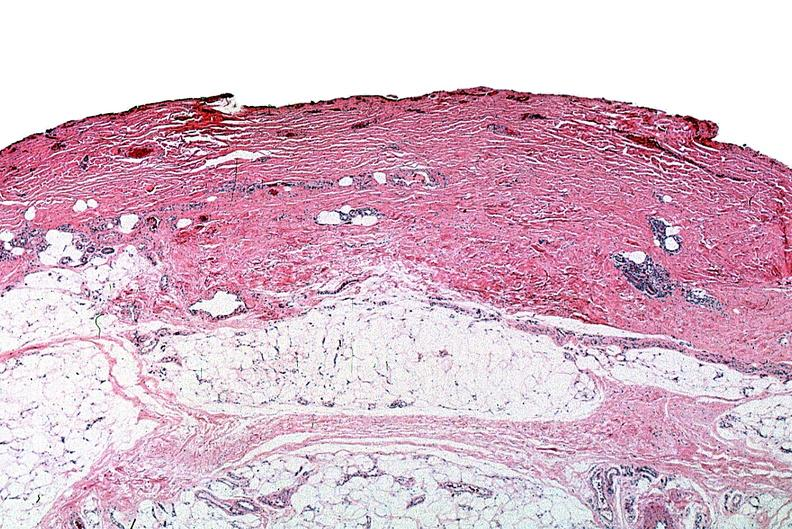where is this?
Answer the question using a single word or phrase. Skin 